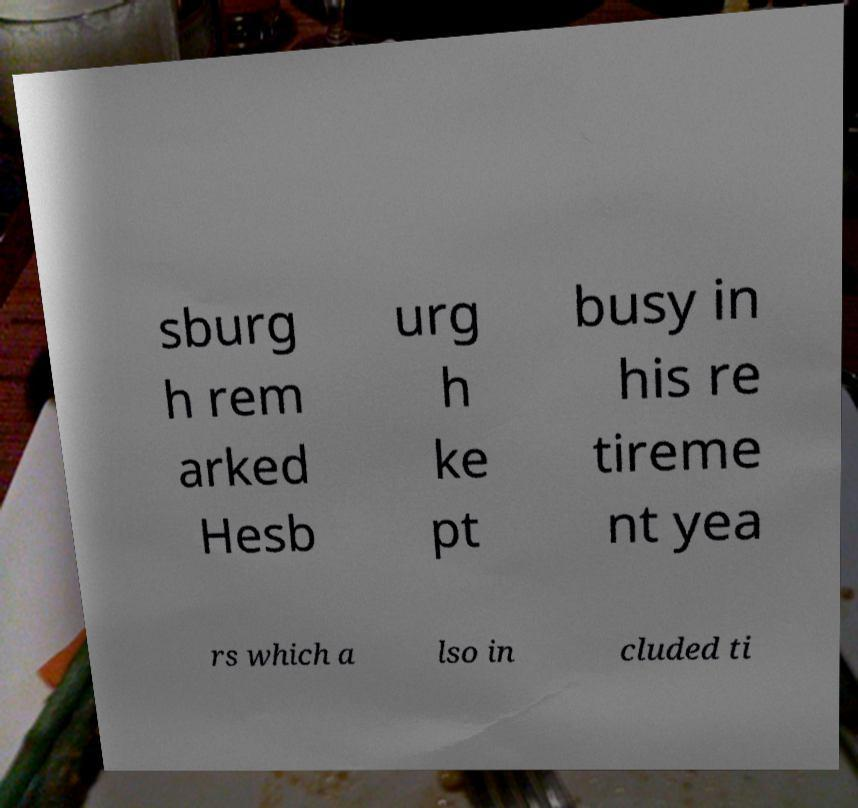Please identify and transcribe the text found in this image. sburg h rem arked Hesb urg h ke pt busy in his re tireme nt yea rs which a lso in cluded ti 